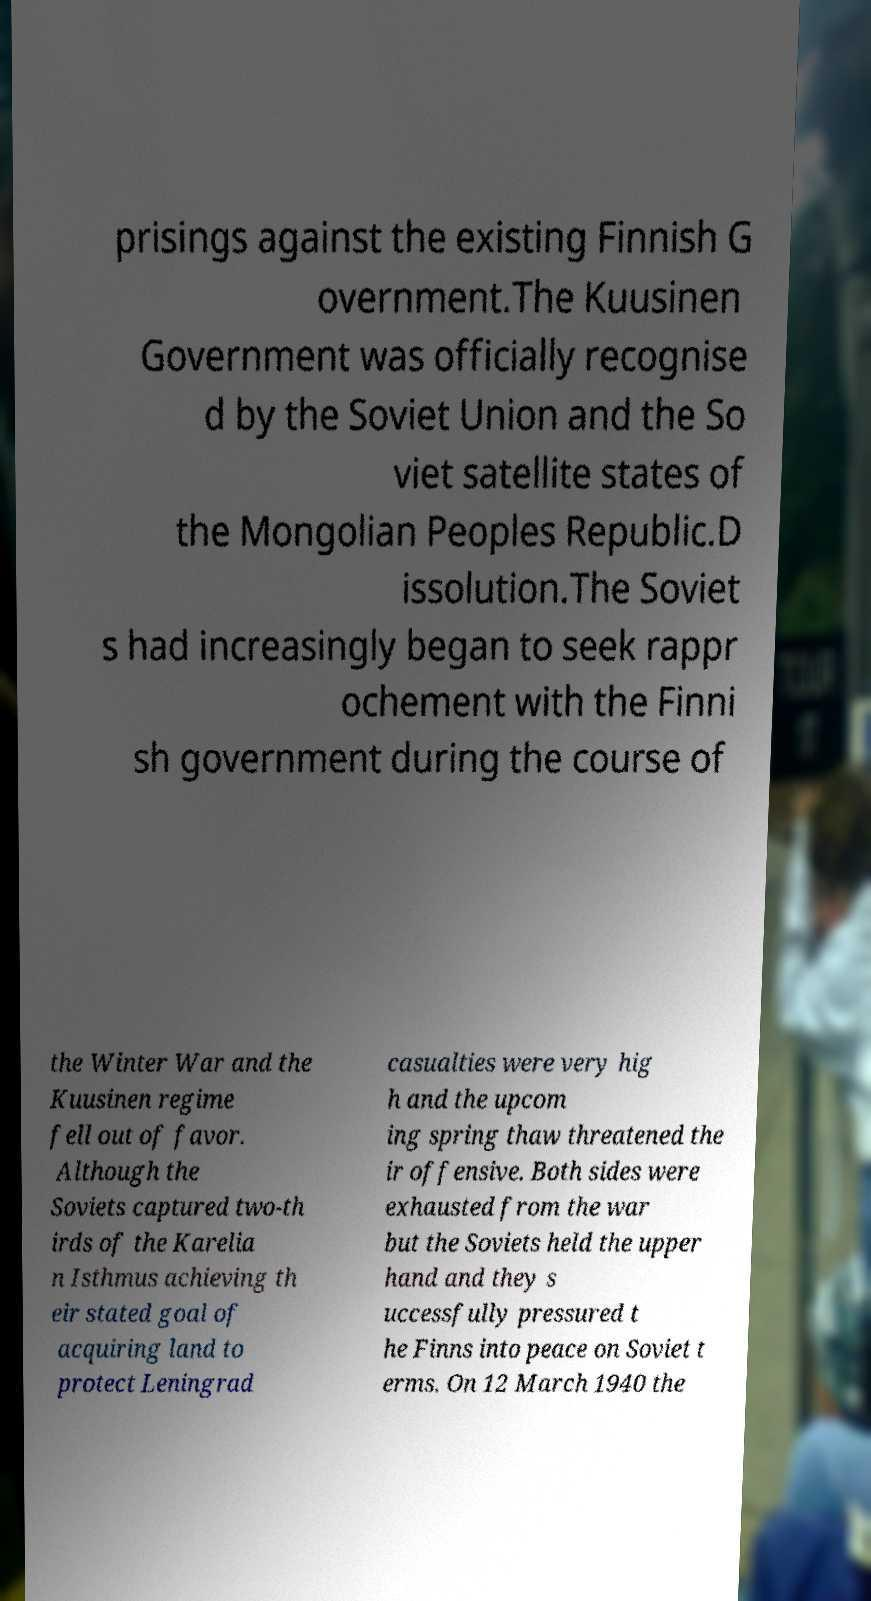What messages or text are displayed in this image? I need them in a readable, typed format. prisings against the existing Finnish G overnment.The Kuusinen Government was officially recognise d by the Soviet Union and the So viet satellite states of the Mongolian Peoples Republic.D issolution.The Soviet s had increasingly began to seek rappr ochement with the Finni sh government during the course of the Winter War and the Kuusinen regime fell out of favor. Although the Soviets captured two-th irds of the Karelia n Isthmus achieving th eir stated goal of acquiring land to protect Leningrad casualties were very hig h and the upcom ing spring thaw threatened the ir offensive. Both sides were exhausted from the war but the Soviets held the upper hand and they s uccessfully pressured t he Finns into peace on Soviet t erms. On 12 March 1940 the 